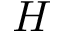Convert formula to latex. <formula><loc_0><loc_0><loc_500><loc_500>H</formula> 